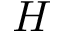Convert formula to latex. <formula><loc_0><loc_0><loc_500><loc_500>H</formula> 